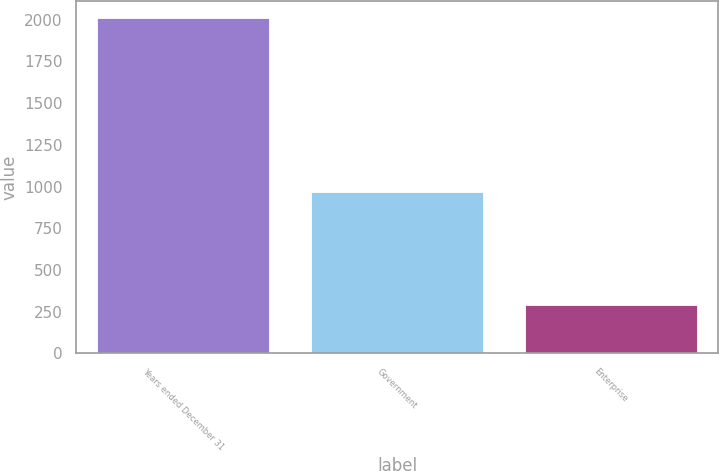Convert chart. <chart><loc_0><loc_0><loc_500><loc_500><bar_chart><fcel>Years ended December 31<fcel>Government<fcel>Enterprise<nl><fcel>2012<fcel>965<fcel>291<nl></chart> 